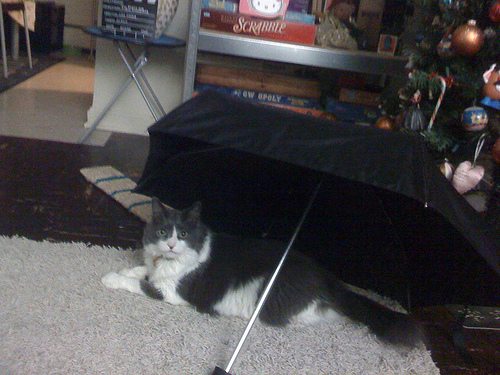Extract all visible text content from this image. SCRABRLE 